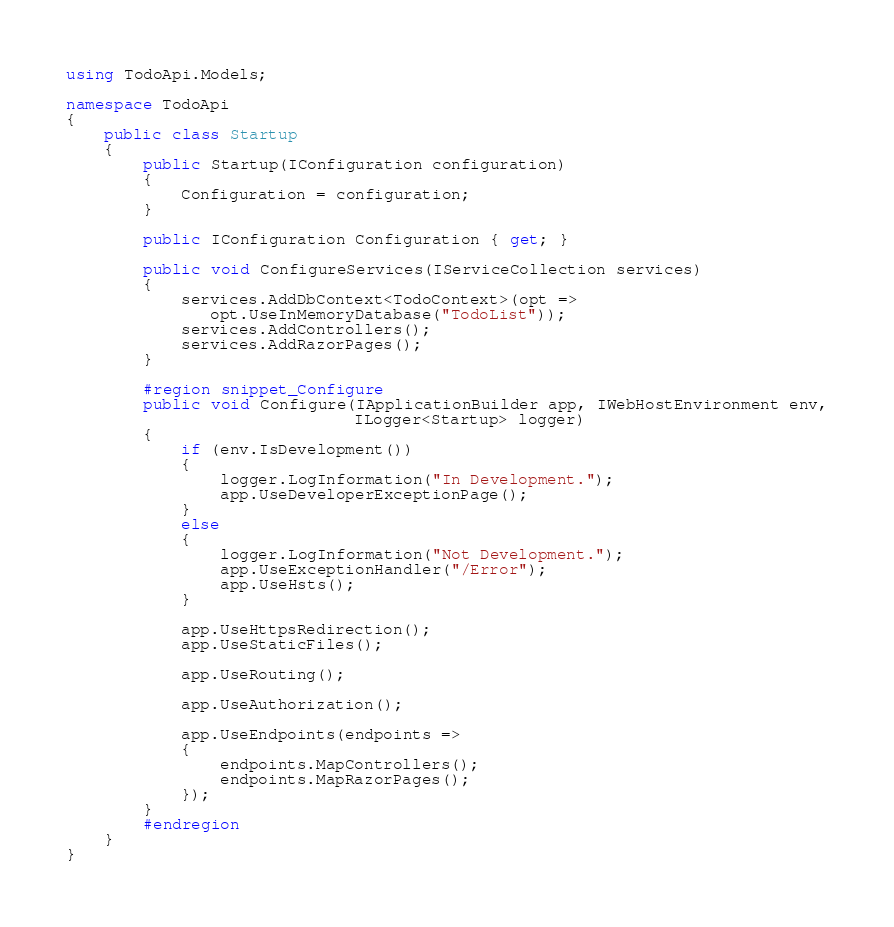<code> <loc_0><loc_0><loc_500><loc_500><_C#_>using TodoApi.Models;

namespace TodoApi
{
    public class Startup
    {
        public Startup(IConfiguration configuration)
        {
            Configuration = configuration;
        }

        public IConfiguration Configuration { get; }

        public void ConfigureServices(IServiceCollection services)
        {
            services.AddDbContext<TodoContext>(opt =>
               opt.UseInMemoryDatabase("TodoList"));
            services.AddControllers();
            services.AddRazorPages();
        }

        #region snippet_Configure
        public void Configure(IApplicationBuilder app, IWebHostEnvironment env,
                              ILogger<Startup> logger)
        {
            if (env.IsDevelopment())
            {
                logger.LogInformation("In Development.");
                app.UseDeveloperExceptionPage();
            }
            else
            {
                logger.LogInformation("Not Development.");
                app.UseExceptionHandler("/Error");
                app.UseHsts();
            }

            app.UseHttpsRedirection();
            app.UseStaticFiles();

            app.UseRouting();

            app.UseAuthorization();

            app.UseEndpoints(endpoints =>
            {
                endpoints.MapControllers();
                endpoints.MapRazorPages();
            });
        }
        #endregion
    }
}
</code> 